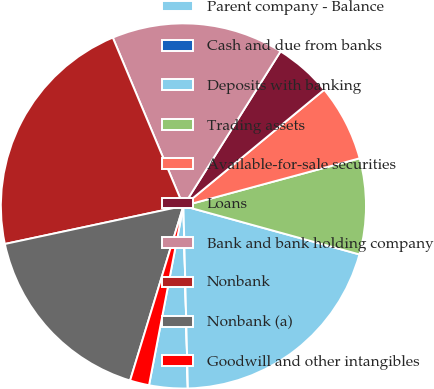<chart> <loc_0><loc_0><loc_500><loc_500><pie_chart><fcel>Parent company - Balance<fcel>Cash and due from banks<fcel>Deposits with banking<fcel>Trading assets<fcel>Available-for-sale securities<fcel>Loans<fcel>Bank and bank holding company<fcel>Nonbank<fcel>Nonbank (a)<fcel>Goodwill and other intangibles<nl><fcel>3.4%<fcel>0.01%<fcel>20.33%<fcel>8.48%<fcel>6.78%<fcel>5.09%<fcel>15.25%<fcel>22.02%<fcel>16.94%<fcel>1.7%<nl></chart> 